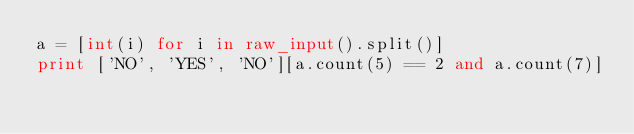<code> <loc_0><loc_0><loc_500><loc_500><_Python_>a = [int(i) for i in raw_input().split()]
print ['NO', 'YES', 'NO'][a.count(5) == 2 and a.count(7)]</code> 